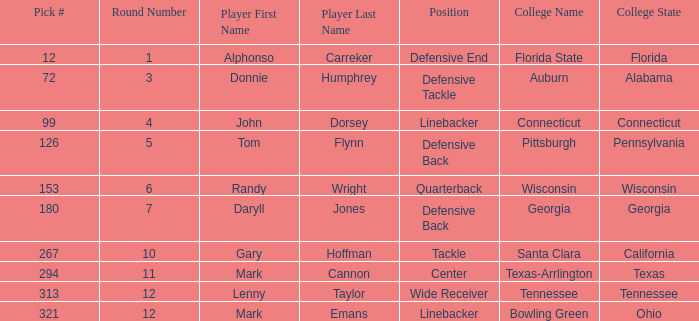In what Round was a player from College of Connecticut drafted? Round 4. 